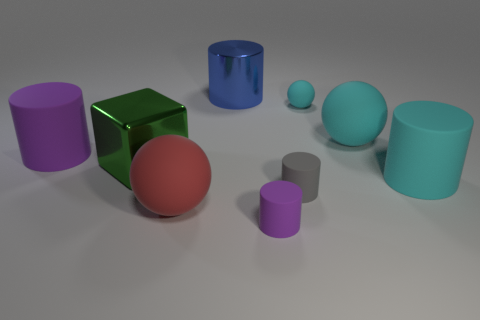What material do the objects appear to be made of, and how can you tell? The objects in the image have differing finishes that suggest they might be made of materials like plastic or metal. Some have a shiny surface, like the green cube, indicating a reflective material often found in metals or polished plastics. Others are matte, like the purple cylinder, which suggests a non-reflective plastic material. The variation in textures provides a sense of diversity in the composition. 